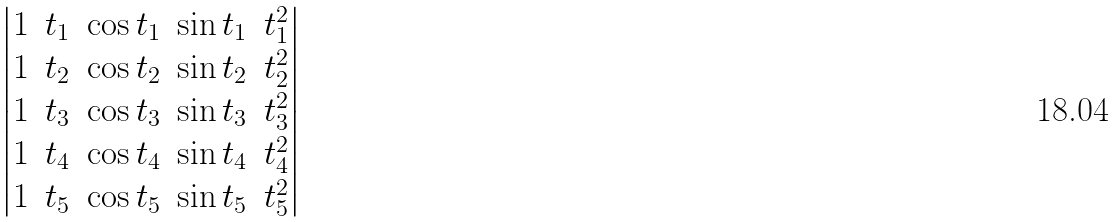Convert formula to latex. <formula><loc_0><loc_0><loc_500><loc_500>\begin{vmatrix} 1 & t _ { 1 } & \cos t _ { 1 } & \sin t _ { 1 } & t _ { 1 } ^ { 2 } \\ 1 & t _ { 2 } & \cos t _ { 2 } & \sin t _ { 2 } & t _ { 2 } ^ { 2 } \\ 1 & t _ { 3 } & \cos t _ { 3 } & \sin t _ { 3 } & t _ { 3 } ^ { 2 } \\ 1 & t _ { 4 } & \cos t _ { 4 } & \sin t _ { 4 } & t _ { 4 } ^ { 2 } \\ 1 & t _ { 5 } & \cos t _ { 5 } & \sin t _ { 5 } & t _ { 5 } ^ { 2 } \\ \end{vmatrix}</formula> 